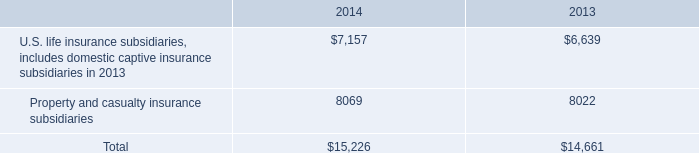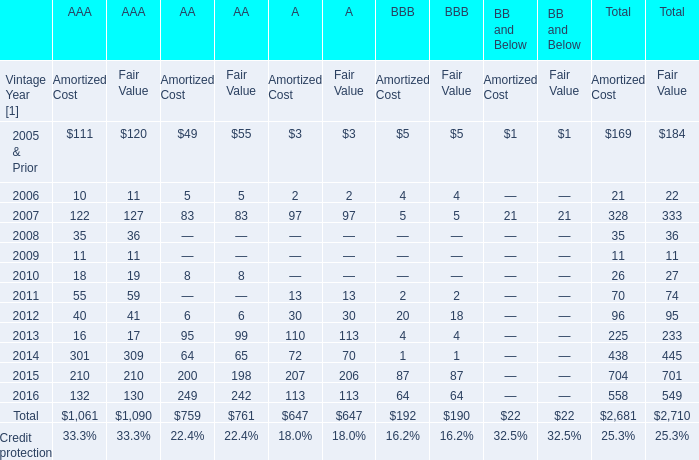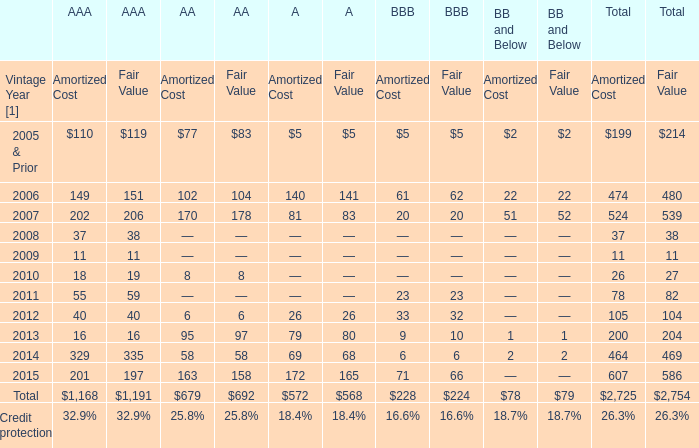How many AAA exceed the average of AAA in 2006? 
Answer: 1. 